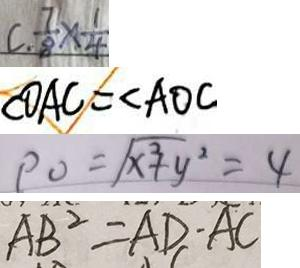Convert formula to latex. <formula><loc_0><loc_0><loc_500><loc_500>C . \frac { 7 } { 8 } \times \frac { 1 } { 4 } 
 \angle O A C = \angle A O C 
 \rho _ { 0 } = \sqrt { x ^ { 3 } + y ^ { 2 } } = 4 
 A B ^ { 2 } = A D - A C</formula> 